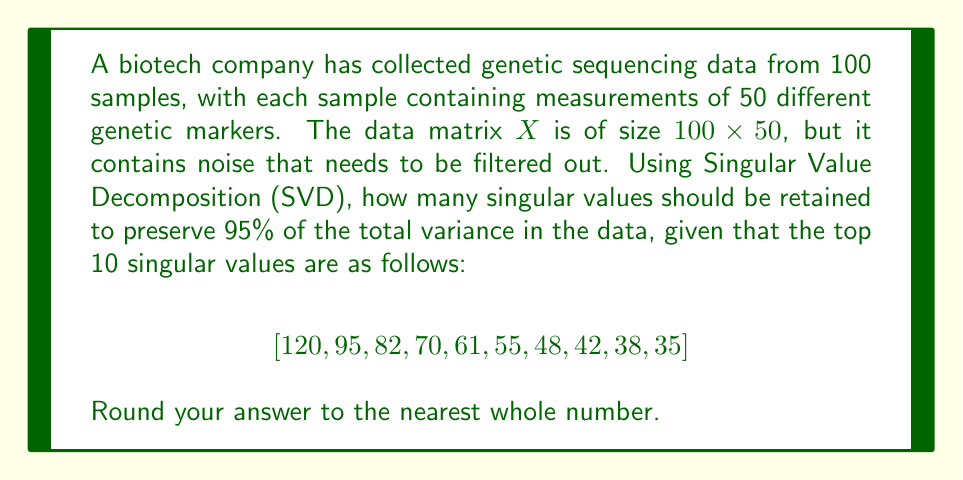Give your solution to this math problem. To solve this problem, we'll use Singular Value Decomposition (SVD) and the concept of explained variance. Here's the step-by-step approach:

1) In SVD, a matrix $X$ is decomposed as $X = U\Sigma V^T$, where $\Sigma$ contains the singular values on its diagonal.

2) The total variance in the data is equal to the sum of squares of all singular values. However, we're only given the top 10 singular values.

3) Let's calculate the sum of squares of the given singular values:

   $\sum_{i=1}^{10} \sigma_i^2 = 120^2 + 95^2 + 82^2 + 70^2 + 61^2 + 55^2 + 48^2 + 42^2 + 38^2 + 35^2 = 61,244$

4) To find how many singular values to retain for 95% of the variance, we need to find the smallest $k$ such that:

   $\frac{\sum_{i=1}^k \sigma_i^2}{\sum_{i=1}^{10} \sigma_i^2} \geq 0.95$

5) Let's calculate this ratio for increasing values of $k$:

   For $k=1$: $\frac{120^2}{61,244} = 0.2352$ (23.52%)
   For $k=2$: $\frac{120^2 + 95^2}{61,244} = 0.4089$ (40.89%)
   For $k=3$: $\frac{120^2 + 95^2 + 82^2}{61,244} = 0.5485$ (54.85%)
   For $k=4$: $\frac{120^2 + 95^2 + 82^2 + 70^2}{61,244} = 0.6579$ (65.79%)
   For $k=5$: $\frac{120^2 + 95^2 + 82^2 + 70^2 + 61^2}{61,244} = 0.7438$ (74.38%)
   For $k=6$: $\frac{120^2 + 95^2 + 82^2 + 70^2 + 61^2 + 55^2}{61,244} = 0.8145$ (81.45%)
   For $k=7$: $\frac{120^2 + 95^2 + 82^2 + 70^2 + 61^2 + 55^2 + 48^2}{61,244} = 0.8706$ (87.06%)
   For $k=8$: $\frac{120^2 + 95^2 + 82^2 + 70^2 + 61^2 + 55^2 + 48^2 + 42^2}{61,244} = 0.9147$ (91.47%)
   For $k=9$: $\frac{120^2 + 95^2 + 82^2 + 70^2 + 61^2 + 55^2 + 48^2 + 42^2 + 38^2}{61,244} = 0.9509$ (95.09%)

6) We see that for $k=9$, we exceed 95% of the total variance.

Therefore, we need to retain 9 singular values to preserve at least 95% of the total variance in the data.
Answer: 9 